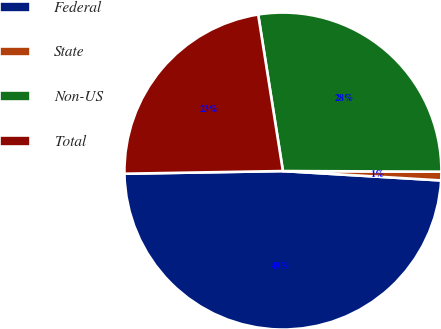Convert chart. <chart><loc_0><loc_0><loc_500><loc_500><pie_chart><fcel>Federal<fcel>State<fcel>Non-US<fcel>Total<nl><fcel>48.78%<fcel>0.88%<fcel>27.56%<fcel>22.77%<nl></chart> 